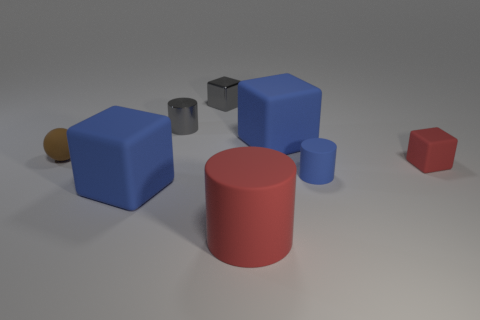Subtract all metallic cubes. How many cubes are left? 3 Subtract all blue cylinders. How many blue blocks are left? 2 Subtract 2 blocks. How many blocks are left? 2 Add 2 tiny blocks. How many objects exist? 10 Subtract all red cylinders. How many cylinders are left? 2 Subtract all green cylinders. Subtract all blue blocks. How many cylinders are left? 3 Subtract 1 blue cylinders. How many objects are left? 7 Subtract all balls. How many objects are left? 7 Subtract all big metal cylinders. Subtract all balls. How many objects are left? 7 Add 3 large red objects. How many large red objects are left? 4 